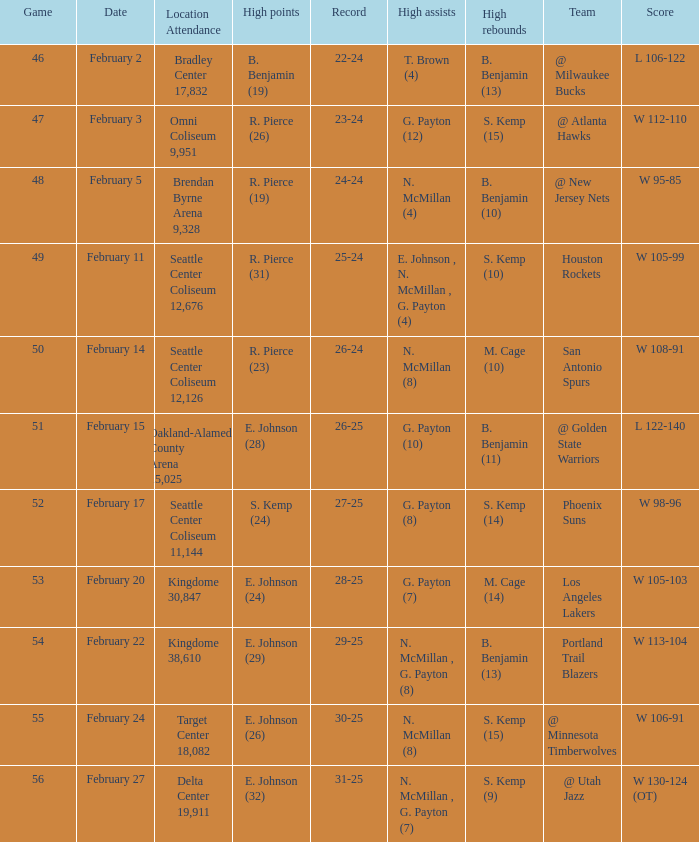What date was the game played in seattle center coliseum 12,126? February 14. Could you help me parse every detail presented in this table? {'header': ['Game', 'Date', 'Location Attendance', 'High points', 'Record', 'High assists', 'High rebounds', 'Team', 'Score'], 'rows': [['46', 'February 2', 'Bradley Center 17,832', 'B. Benjamin (19)', '22-24', 'T. Brown (4)', 'B. Benjamin (13)', '@ Milwaukee Bucks', 'L 106-122'], ['47', 'February 3', 'Omni Coliseum 9,951', 'R. Pierce (26)', '23-24', 'G. Payton (12)', 'S. Kemp (15)', '@ Atlanta Hawks', 'W 112-110'], ['48', 'February 5', 'Brendan Byrne Arena 9,328', 'R. Pierce (19)', '24-24', 'N. McMillan (4)', 'B. Benjamin (10)', '@ New Jersey Nets', 'W 95-85'], ['49', 'February 11', 'Seattle Center Coliseum 12,676', 'R. Pierce (31)', '25-24', 'E. Johnson , N. McMillan , G. Payton (4)', 'S. Kemp (10)', 'Houston Rockets', 'W 105-99'], ['50', 'February 14', 'Seattle Center Coliseum 12,126', 'R. Pierce (23)', '26-24', 'N. McMillan (8)', 'M. Cage (10)', 'San Antonio Spurs', 'W 108-91'], ['51', 'February 15', 'Oakland-Alameda County Arena 15,025', 'E. Johnson (28)', '26-25', 'G. Payton (10)', 'B. Benjamin (11)', '@ Golden State Warriors', 'L 122-140'], ['52', 'February 17', 'Seattle Center Coliseum 11,144', 'S. Kemp (24)', '27-25', 'G. Payton (8)', 'S. Kemp (14)', 'Phoenix Suns', 'W 98-96'], ['53', 'February 20', 'Kingdome 30,847', 'E. Johnson (24)', '28-25', 'G. Payton (7)', 'M. Cage (14)', 'Los Angeles Lakers', 'W 105-103'], ['54', 'February 22', 'Kingdome 38,610', 'E. Johnson (29)', '29-25', 'N. McMillan , G. Payton (8)', 'B. Benjamin (13)', 'Portland Trail Blazers', 'W 113-104'], ['55', 'February 24', 'Target Center 18,082', 'E. Johnson (26)', '30-25', 'N. McMillan (8)', 'S. Kemp (15)', '@ Minnesota Timberwolves', 'W 106-91'], ['56', 'February 27', 'Delta Center 19,911', 'E. Johnson (32)', '31-25', 'N. McMillan , G. Payton (7)', 'S. Kemp (9)', '@ Utah Jazz', 'W 130-124 (OT)']]} 